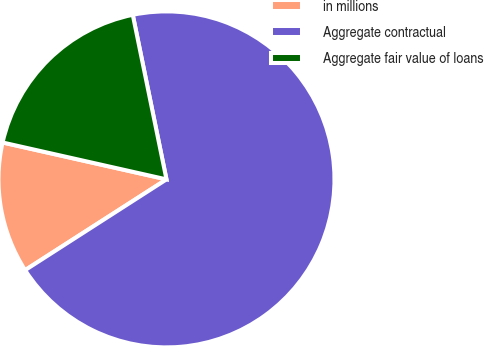Convert chart to OTSL. <chart><loc_0><loc_0><loc_500><loc_500><pie_chart><fcel>in millions<fcel>Aggregate contractual<fcel>Aggregate fair value of loans<nl><fcel>12.61%<fcel>69.14%<fcel>18.26%<nl></chart> 